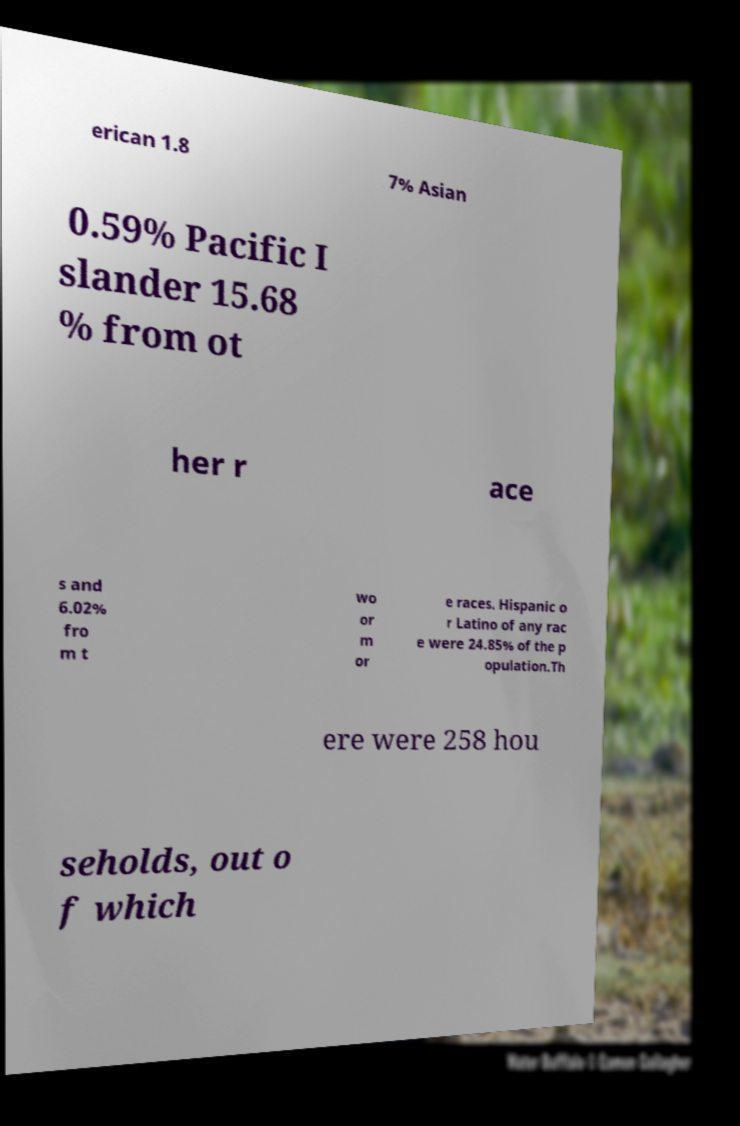There's text embedded in this image that I need extracted. Can you transcribe it verbatim? erican 1.8 7% Asian 0.59% Pacific I slander 15.68 % from ot her r ace s and 6.02% fro m t wo or m or e races. Hispanic o r Latino of any rac e were 24.85% of the p opulation.Th ere were 258 hou seholds, out o f which 